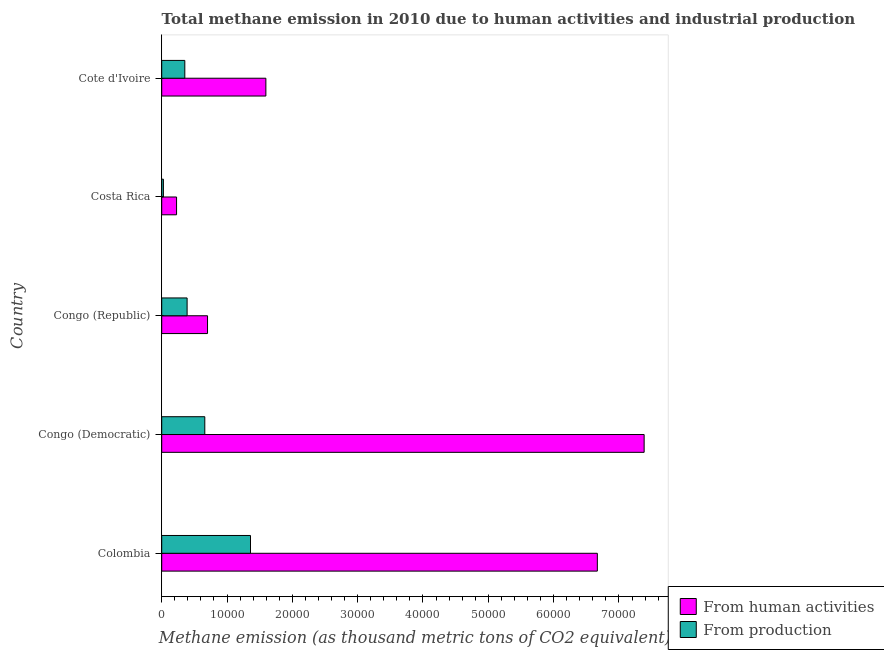How many different coloured bars are there?
Offer a terse response. 2. Are the number of bars per tick equal to the number of legend labels?
Provide a short and direct response. Yes. How many bars are there on the 5th tick from the top?
Your answer should be very brief. 2. How many bars are there on the 4th tick from the bottom?
Keep it short and to the point. 2. What is the amount of emissions generated from industries in Congo (Democratic)?
Your response must be concise. 6595.4. Across all countries, what is the maximum amount of emissions from human activities?
Ensure brevity in your answer.  7.39e+04. Across all countries, what is the minimum amount of emissions from human activities?
Ensure brevity in your answer.  2273.7. In which country was the amount of emissions from human activities maximum?
Ensure brevity in your answer.  Congo (Democratic). In which country was the amount of emissions generated from industries minimum?
Your answer should be compact. Costa Rica. What is the total amount of emissions from human activities in the graph?
Your response must be concise. 1.66e+05. What is the difference between the amount of emissions generated from industries in Congo (Democratic) and that in Costa Rica?
Keep it short and to the point. 6336.5. What is the difference between the amount of emissions from human activities in Congo (Democratic) and the amount of emissions generated from industries in Congo (Republic)?
Your response must be concise. 7.00e+04. What is the average amount of emissions generated from industries per country?
Offer a terse response. 5574.48. What is the difference between the amount of emissions from human activities and amount of emissions generated from industries in Cote d'Ivoire?
Ensure brevity in your answer.  1.24e+04. What is the ratio of the amount of emissions from human activities in Colombia to that in Cote d'Ivoire?
Offer a terse response. 4.18. What is the difference between the highest and the second highest amount of emissions from human activities?
Provide a succinct answer. 7164.8. What is the difference between the highest and the lowest amount of emissions from human activities?
Provide a short and direct response. 7.16e+04. In how many countries, is the amount of emissions generated from industries greater than the average amount of emissions generated from industries taken over all countries?
Offer a terse response. 2. What does the 2nd bar from the top in Costa Rica represents?
Offer a terse response. From human activities. What does the 2nd bar from the bottom in Colombia represents?
Provide a short and direct response. From production. How many bars are there?
Offer a terse response. 10. What is the difference between two consecutive major ticks on the X-axis?
Make the answer very short. 10000. Are the values on the major ticks of X-axis written in scientific E-notation?
Ensure brevity in your answer.  No. Does the graph contain any zero values?
Ensure brevity in your answer.  No. Does the graph contain grids?
Offer a very short reply. No. What is the title of the graph?
Offer a very short reply. Total methane emission in 2010 due to human activities and industrial production. What is the label or title of the X-axis?
Make the answer very short. Methane emission (as thousand metric tons of CO2 equivalent). What is the Methane emission (as thousand metric tons of CO2 equivalent) in From human activities in Colombia?
Give a very brief answer. 6.67e+04. What is the Methane emission (as thousand metric tons of CO2 equivalent) in From production in Colombia?
Ensure brevity in your answer.  1.36e+04. What is the Methane emission (as thousand metric tons of CO2 equivalent) of From human activities in Congo (Democratic)?
Keep it short and to the point. 7.39e+04. What is the Methane emission (as thousand metric tons of CO2 equivalent) of From production in Congo (Democratic)?
Provide a short and direct response. 6595.4. What is the Methane emission (as thousand metric tons of CO2 equivalent) in From human activities in Congo (Republic)?
Give a very brief answer. 7016. What is the Methane emission (as thousand metric tons of CO2 equivalent) in From production in Congo (Republic)?
Offer a very short reply. 3887.3. What is the Methane emission (as thousand metric tons of CO2 equivalent) of From human activities in Costa Rica?
Your answer should be very brief. 2273.7. What is the Methane emission (as thousand metric tons of CO2 equivalent) in From production in Costa Rica?
Give a very brief answer. 258.9. What is the Methane emission (as thousand metric tons of CO2 equivalent) in From human activities in Cote d'Ivoire?
Give a very brief answer. 1.59e+04. What is the Methane emission (as thousand metric tons of CO2 equivalent) in From production in Cote d'Ivoire?
Make the answer very short. 3537.3. Across all countries, what is the maximum Methane emission (as thousand metric tons of CO2 equivalent) of From human activities?
Provide a short and direct response. 7.39e+04. Across all countries, what is the maximum Methane emission (as thousand metric tons of CO2 equivalent) in From production?
Offer a terse response. 1.36e+04. Across all countries, what is the minimum Methane emission (as thousand metric tons of CO2 equivalent) in From human activities?
Your answer should be compact. 2273.7. Across all countries, what is the minimum Methane emission (as thousand metric tons of CO2 equivalent) of From production?
Your answer should be very brief. 258.9. What is the total Methane emission (as thousand metric tons of CO2 equivalent) of From human activities in the graph?
Your answer should be very brief. 1.66e+05. What is the total Methane emission (as thousand metric tons of CO2 equivalent) of From production in the graph?
Your response must be concise. 2.79e+04. What is the difference between the Methane emission (as thousand metric tons of CO2 equivalent) of From human activities in Colombia and that in Congo (Democratic)?
Offer a very short reply. -7164.8. What is the difference between the Methane emission (as thousand metric tons of CO2 equivalent) of From production in Colombia and that in Congo (Democratic)?
Your response must be concise. 6998.1. What is the difference between the Methane emission (as thousand metric tons of CO2 equivalent) of From human activities in Colombia and that in Congo (Republic)?
Ensure brevity in your answer.  5.97e+04. What is the difference between the Methane emission (as thousand metric tons of CO2 equivalent) of From production in Colombia and that in Congo (Republic)?
Ensure brevity in your answer.  9706.2. What is the difference between the Methane emission (as thousand metric tons of CO2 equivalent) of From human activities in Colombia and that in Costa Rica?
Provide a succinct answer. 6.44e+04. What is the difference between the Methane emission (as thousand metric tons of CO2 equivalent) in From production in Colombia and that in Costa Rica?
Give a very brief answer. 1.33e+04. What is the difference between the Methane emission (as thousand metric tons of CO2 equivalent) in From human activities in Colombia and that in Cote d'Ivoire?
Ensure brevity in your answer.  5.07e+04. What is the difference between the Methane emission (as thousand metric tons of CO2 equivalent) in From production in Colombia and that in Cote d'Ivoire?
Give a very brief answer. 1.01e+04. What is the difference between the Methane emission (as thousand metric tons of CO2 equivalent) in From human activities in Congo (Democratic) and that in Congo (Republic)?
Keep it short and to the point. 6.68e+04. What is the difference between the Methane emission (as thousand metric tons of CO2 equivalent) in From production in Congo (Democratic) and that in Congo (Republic)?
Keep it short and to the point. 2708.1. What is the difference between the Methane emission (as thousand metric tons of CO2 equivalent) in From human activities in Congo (Democratic) and that in Costa Rica?
Offer a terse response. 7.16e+04. What is the difference between the Methane emission (as thousand metric tons of CO2 equivalent) in From production in Congo (Democratic) and that in Costa Rica?
Keep it short and to the point. 6336.5. What is the difference between the Methane emission (as thousand metric tons of CO2 equivalent) in From human activities in Congo (Democratic) and that in Cote d'Ivoire?
Your answer should be very brief. 5.79e+04. What is the difference between the Methane emission (as thousand metric tons of CO2 equivalent) of From production in Congo (Democratic) and that in Cote d'Ivoire?
Your response must be concise. 3058.1. What is the difference between the Methane emission (as thousand metric tons of CO2 equivalent) of From human activities in Congo (Republic) and that in Costa Rica?
Your response must be concise. 4742.3. What is the difference between the Methane emission (as thousand metric tons of CO2 equivalent) of From production in Congo (Republic) and that in Costa Rica?
Make the answer very short. 3628.4. What is the difference between the Methane emission (as thousand metric tons of CO2 equivalent) in From human activities in Congo (Republic) and that in Cote d'Ivoire?
Give a very brief answer. -8930.8. What is the difference between the Methane emission (as thousand metric tons of CO2 equivalent) in From production in Congo (Republic) and that in Cote d'Ivoire?
Provide a succinct answer. 350. What is the difference between the Methane emission (as thousand metric tons of CO2 equivalent) in From human activities in Costa Rica and that in Cote d'Ivoire?
Your answer should be very brief. -1.37e+04. What is the difference between the Methane emission (as thousand metric tons of CO2 equivalent) in From production in Costa Rica and that in Cote d'Ivoire?
Provide a short and direct response. -3278.4. What is the difference between the Methane emission (as thousand metric tons of CO2 equivalent) in From human activities in Colombia and the Methane emission (as thousand metric tons of CO2 equivalent) in From production in Congo (Democratic)?
Keep it short and to the point. 6.01e+04. What is the difference between the Methane emission (as thousand metric tons of CO2 equivalent) of From human activities in Colombia and the Methane emission (as thousand metric tons of CO2 equivalent) of From production in Congo (Republic)?
Your answer should be compact. 6.28e+04. What is the difference between the Methane emission (as thousand metric tons of CO2 equivalent) in From human activities in Colombia and the Methane emission (as thousand metric tons of CO2 equivalent) in From production in Costa Rica?
Give a very brief answer. 6.64e+04. What is the difference between the Methane emission (as thousand metric tons of CO2 equivalent) of From human activities in Colombia and the Methane emission (as thousand metric tons of CO2 equivalent) of From production in Cote d'Ivoire?
Make the answer very short. 6.32e+04. What is the difference between the Methane emission (as thousand metric tons of CO2 equivalent) of From human activities in Congo (Democratic) and the Methane emission (as thousand metric tons of CO2 equivalent) of From production in Congo (Republic)?
Ensure brevity in your answer.  7.00e+04. What is the difference between the Methane emission (as thousand metric tons of CO2 equivalent) in From human activities in Congo (Democratic) and the Methane emission (as thousand metric tons of CO2 equivalent) in From production in Costa Rica?
Give a very brief answer. 7.36e+04. What is the difference between the Methane emission (as thousand metric tons of CO2 equivalent) of From human activities in Congo (Democratic) and the Methane emission (as thousand metric tons of CO2 equivalent) of From production in Cote d'Ivoire?
Your answer should be compact. 7.03e+04. What is the difference between the Methane emission (as thousand metric tons of CO2 equivalent) of From human activities in Congo (Republic) and the Methane emission (as thousand metric tons of CO2 equivalent) of From production in Costa Rica?
Offer a very short reply. 6757.1. What is the difference between the Methane emission (as thousand metric tons of CO2 equivalent) in From human activities in Congo (Republic) and the Methane emission (as thousand metric tons of CO2 equivalent) in From production in Cote d'Ivoire?
Give a very brief answer. 3478.7. What is the difference between the Methane emission (as thousand metric tons of CO2 equivalent) in From human activities in Costa Rica and the Methane emission (as thousand metric tons of CO2 equivalent) in From production in Cote d'Ivoire?
Give a very brief answer. -1263.6. What is the average Methane emission (as thousand metric tons of CO2 equivalent) of From human activities per country?
Provide a short and direct response. 3.32e+04. What is the average Methane emission (as thousand metric tons of CO2 equivalent) in From production per country?
Provide a short and direct response. 5574.48. What is the difference between the Methane emission (as thousand metric tons of CO2 equivalent) in From human activities and Methane emission (as thousand metric tons of CO2 equivalent) in From production in Colombia?
Keep it short and to the point. 5.31e+04. What is the difference between the Methane emission (as thousand metric tons of CO2 equivalent) in From human activities and Methane emission (as thousand metric tons of CO2 equivalent) in From production in Congo (Democratic)?
Your answer should be compact. 6.73e+04. What is the difference between the Methane emission (as thousand metric tons of CO2 equivalent) in From human activities and Methane emission (as thousand metric tons of CO2 equivalent) in From production in Congo (Republic)?
Your response must be concise. 3128.7. What is the difference between the Methane emission (as thousand metric tons of CO2 equivalent) in From human activities and Methane emission (as thousand metric tons of CO2 equivalent) in From production in Costa Rica?
Keep it short and to the point. 2014.8. What is the difference between the Methane emission (as thousand metric tons of CO2 equivalent) in From human activities and Methane emission (as thousand metric tons of CO2 equivalent) in From production in Cote d'Ivoire?
Offer a terse response. 1.24e+04. What is the ratio of the Methane emission (as thousand metric tons of CO2 equivalent) in From human activities in Colombia to that in Congo (Democratic)?
Your response must be concise. 0.9. What is the ratio of the Methane emission (as thousand metric tons of CO2 equivalent) in From production in Colombia to that in Congo (Democratic)?
Ensure brevity in your answer.  2.06. What is the ratio of the Methane emission (as thousand metric tons of CO2 equivalent) of From human activities in Colombia to that in Congo (Republic)?
Make the answer very short. 9.51. What is the ratio of the Methane emission (as thousand metric tons of CO2 equivalent) of From production in Colombia to that in Congo (Republic)?
Give a very brief answer. 3.5. What is the ratio of the Methane emission (as thousand metric tons of CO2 equivalent) of From human activities in Colombia to that in Costa Rica?
Provide a succinct answer. 29.33. What is the ratio of the Methane emission (as thousand metric tons of CO2 equivalent) of From production in Colombia to that in Costa Rica?
Your answer should be compact. 52.5. What is the ratio of the Methane emission (as thousand metric tons of CO2 equivalent) of From human activities in Colombia to that in Cote d'Ivoire?
Offer a terse response. 4.18. What is the ratio of the Methane emission (as thousand metric tons of CO2 equivalent) of From production in Colombia to that in Cote d'Ivoire?
Make the answer very short. 3.84. What is the ratio of the Methane emission (as thousand metric tons of CO2 equivalent) of From human activities in Congo (Democratic) to that in Congo (Republic)?
Your response must be concise. 10.53. What is the ratio of the Methane emission (as thousand metric tons of CO2 equivalent) of From production in Congo (Democratic) to that in Congo (Republic)?
Provide a succinct answer. 1.7. What is the ratio of the Methane emission (as thousand metric tons of CO2 equivalent) of From human activities in Congo (Democratic) to that in Costa Rica?
Offer a terse response. 32.48. What is the ratio of the Methane emission (as thousand metric tons of CO2 equivalent) in From production in Congo (Democratic) to that in Costa Rica?
Ensure brevity in your answer.  25.47. What is the ratio of the Methane emission (as thousand metric tons of CO2 equivalent) of From human activities in Congo (Democratic) to that in Cote d'Ivoire?
Give a very brief answer. 4.63. What is the ratio of the Methane emission (as thousand metric tons of CO2 equivalent) of From production in Congo (Democratic) to that in Cote d'Ivoire?
Provide a succinct answer. 1.86. What is the ratio of the Methane emission (as thousand metric tons of CO2 equivalent) in From human activities in Congo (Republic) to that in Costa Rica?
Offer a very short reply. 3.09. What is the ratio of the Methane emission (as thousand metric tons of CO2 equivalent) of From production in Congo (Republic) to that in Costa Rica?
Keep it short and to the point. 15.01. What is the ratio of the Methane emission (as thousand metric tons of CO2 equivalent) of From human activities in Congo (Republic) to that in Cote d'Ivoire?
Make the answer very short. 0.44. What is the ratio of the Methane emission (as thousand metric tons of CO2 equivalent) of From production in Congo (Republic) to that in Cote d'Ivoire?
Offer a very short reply. 1.1. What is the ratio of the Methane emission (as thousand metric tons of CO2 equivalent) in From human activities in Costa Rica to that in Cote d'Ivoire?
Ensure brevity in your answer.  0.14. What is the ratio of the Methane emission (as thousand metric tons of CO2 equivalent) of From production in Costa Rica to that in Cote d'Ivoire?
Give a very brief answer. 0.07. What is the difference between the highest and the second highest Methane emission (as thousand metric tons of CO2 equivalent) of From human activities?
Keep it short and to the point. 7164.8. What is the difference between the highest and the second highest Methane emission (as thousand metric tons of CO2 equivalent) of From production?
Keep it short and to the point. 6998.1. What is the difference between the highest and the lowest Methane emission (as thousand metric tons of CO2 equivalent) of From human activities?
Your answer should be very brief. 7.16e+04. What is the difference between the highest and the lowest Methane emission (as thousand metric tons of CO2 equivalent) in From production?
Ensure brevity in your answer.  1.33e+04. 